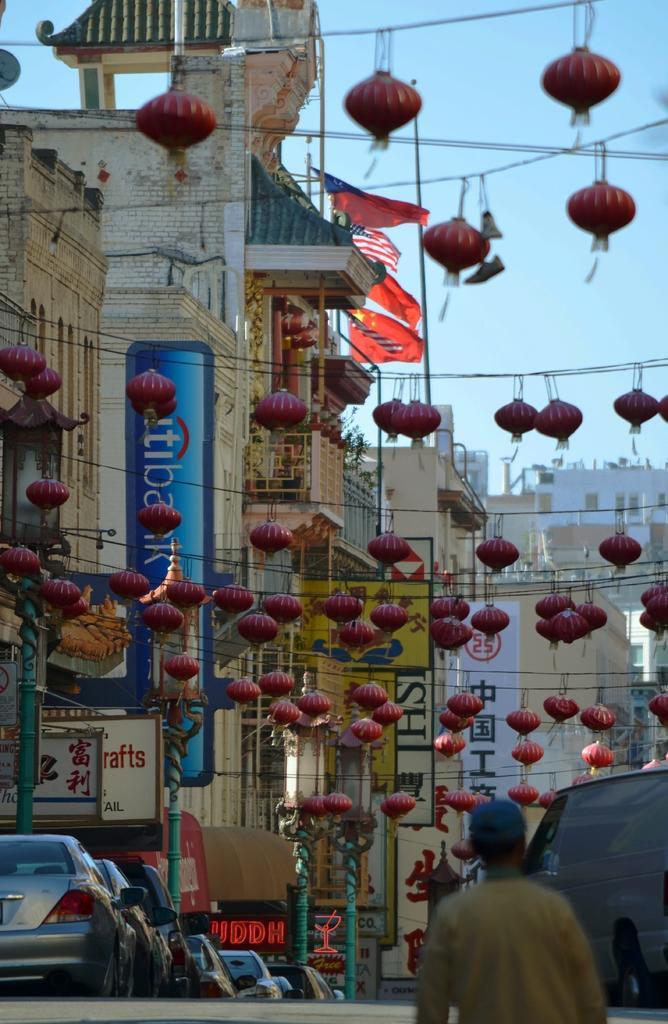Could you give a brief overview of what you see in this image? In this image I can see number of red colour things on the ropes. On the left side of this image I can see few cars and on the ride side I can see one more vehicle. In the front I can see a person and in the background I can see number of buildings, number of poles, for flags, the sky and on these boards I can see something is written. 